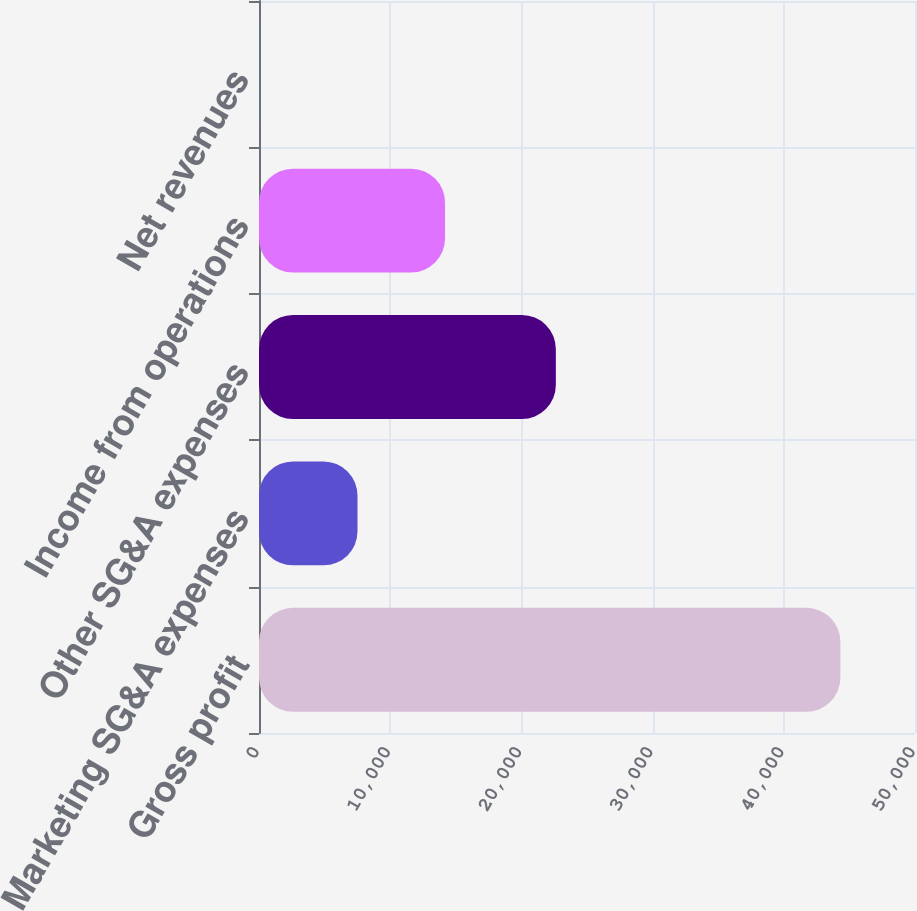Convert chart. <chart><loc_0><loc_0><loc_500><loc_500><bar_chart><fcel>Gross profit<fcel>Marketing SG&A expenses<fcel>Other SG&A expenses<fcel>Income from operations<fcel>Net revenues<nl><fcel>44312<fcel>7507<fcel>22625<fcel>14180<fcel>20.4<nl></chart> 